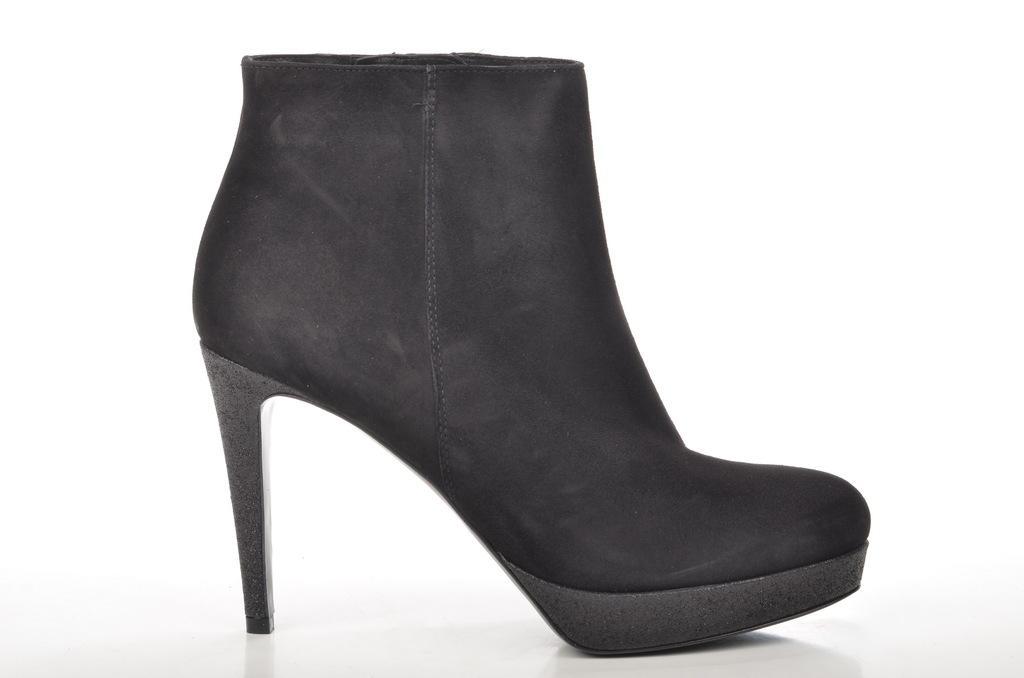Could you give a brief overview of what you see in this image? There is a woman heel shoe which is black in color. 